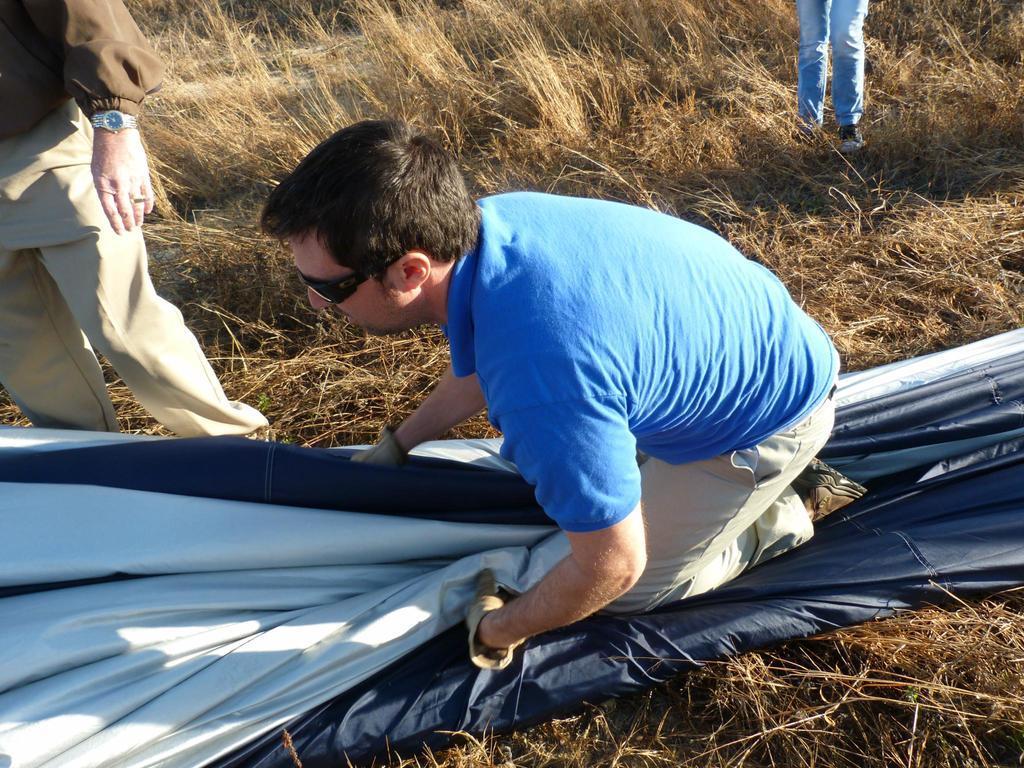In one or two sentences, can you explain what this image depicts? In this image, in the middle we can see a man sitting on an object. There is grass on the ground and we can see two persons standing. 